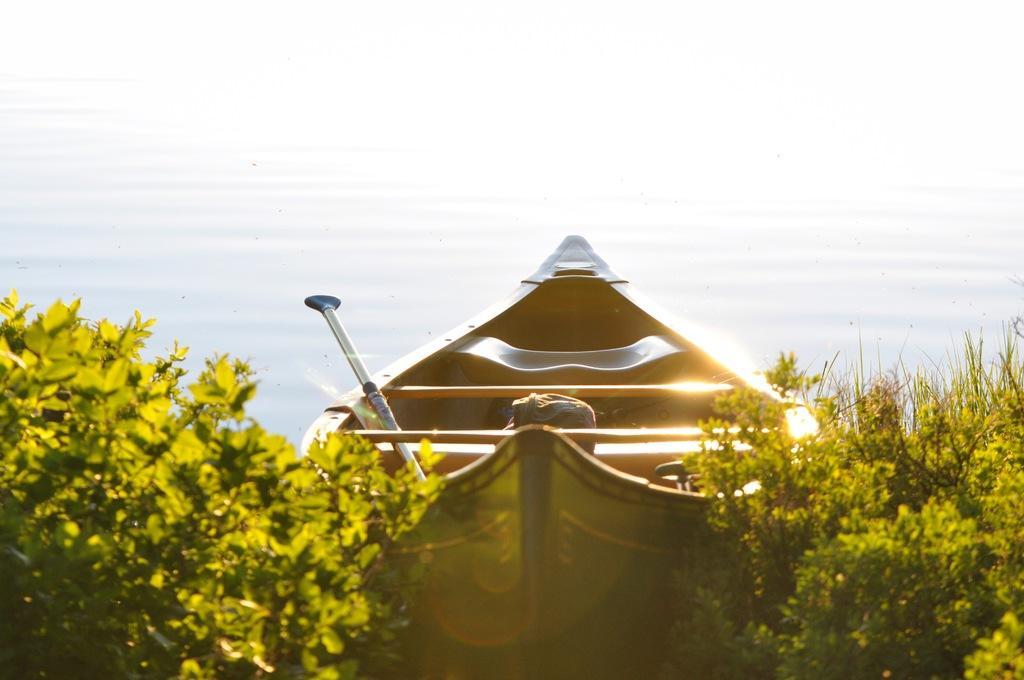Could you give a brief overview of what you see in this image? As we can see in the image there are plants, boat, stick, bag and water. 